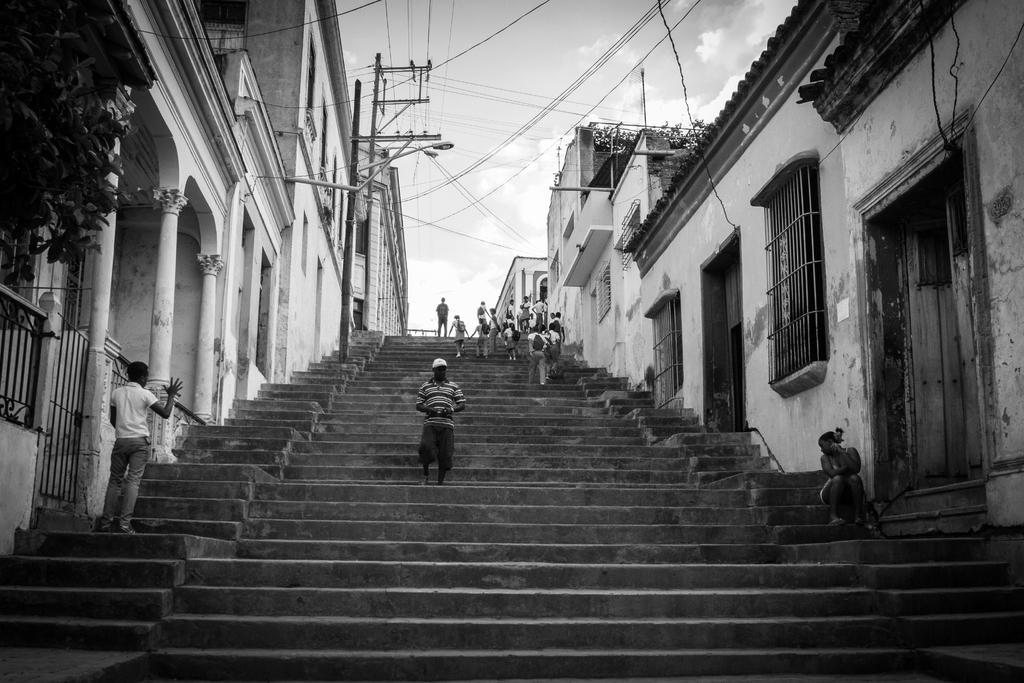Please provide a concise description of this image. In this image there are persons standing, walking and sitting and there are buildings, poles, wires, plants and the sky is cloudy. 